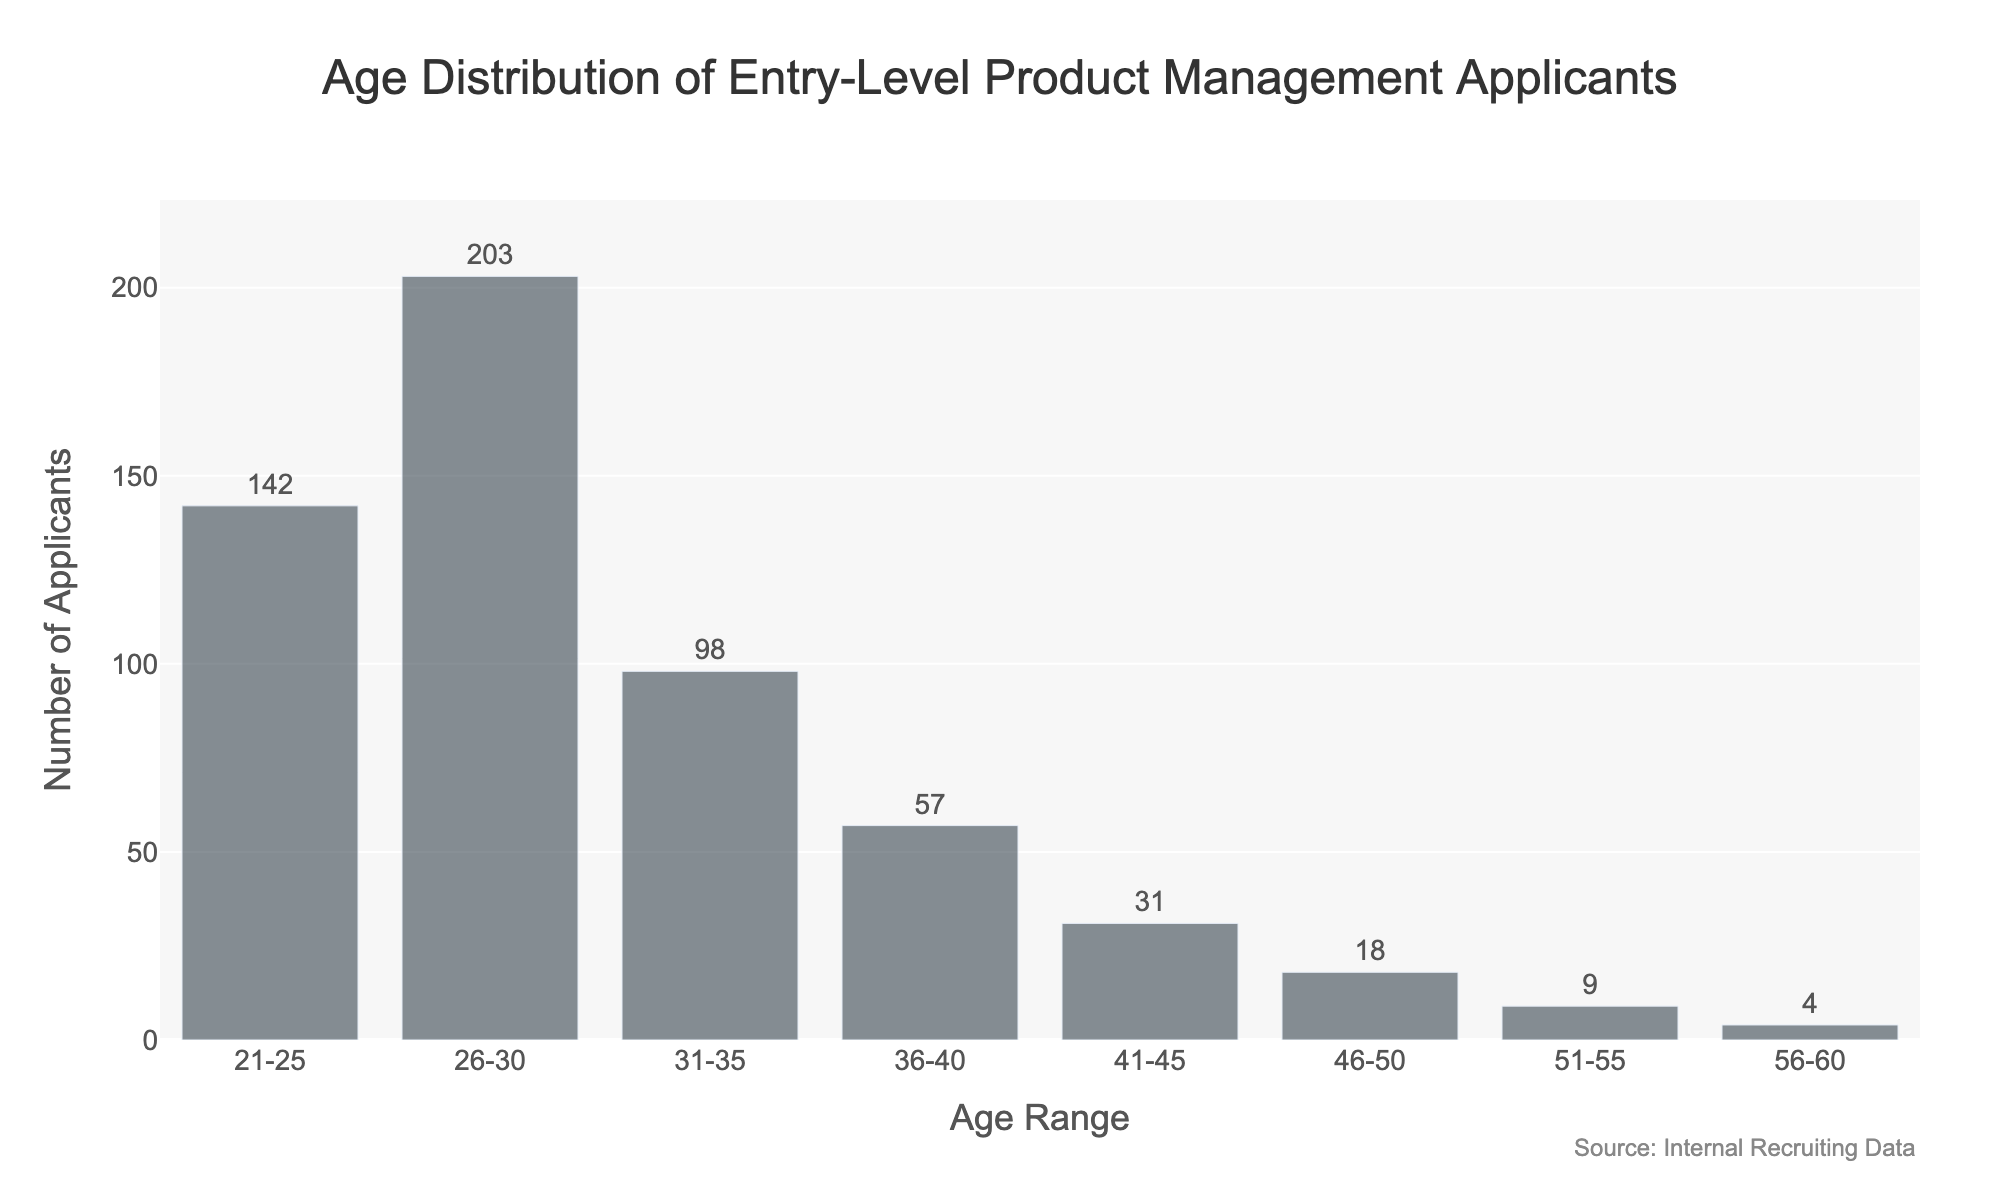What is the title of the figure? The title of the figure is displayed at the top of the chart. It's typically in larger font size and might be centrally aligned.
Answer: Age Distribution of Entry-Level Product Management Applicants What is the age range with the highest number of applicants? Look at the age range on the x-axis and find the corresponding bar with the highest value on the y-axis.
Answer: 26-30 How many applicants are in the 21-25 age range? Refer to the height of the bar on the histogram corresponding to the 21-25 age range and read the text label outside the bar for confirmation.
Answer: 142 Which age range has the lowest number of applicants? Compare the heights of all the bars to find the shortest one and read its label.
Answer: 56-60 What is the total number of applicants in the 31-35 and 36-40 age ranges? Add the number of applicants from the 31-35 age range (98) and the number from the 36-40 age range (57).
Answer: 155 By how much do the applicants in the 26-30 age range outnumber the applicants in the 41-45 age range? Subtract the number of applicants in the 41-45 age range (31) from the number of applicants in the 26-30 age range (203).
Answer: 172 What is the average number of applicants across all age ranges? Sum the numbers of applicants across all age ranges and divide by the number of age ranges. Total applicants are 562 and there are 8 age ranges, so 562 / 8 = 70.25.
Answer: 70.25 How does the number of applicants in the 46-50 age range compare to the number of applicants in the 51-55 age range? Compare the heights of the bars corresponding to these age ranges. The bar for 46-50 has 18 applicants, and the bar for 51-55 has 9 applicants, so 46-50 has twice as many applicants.
Answer: 46-50 has twice as many applicants Which age ranges have more than 100 applicants? Identify bars with heights that represent counts greater than 100 on the y-axis.
Answer: 21-25, 26-30 What percentage of total applicants are in the 26-30 age range? Divide the number of applicants in the 26-30 age range (203) by the total number of applicants (562) and multiply by 100 to get the percentage. 203/562 * 100 ≈ 36.12%.
Answer: 36.12% 